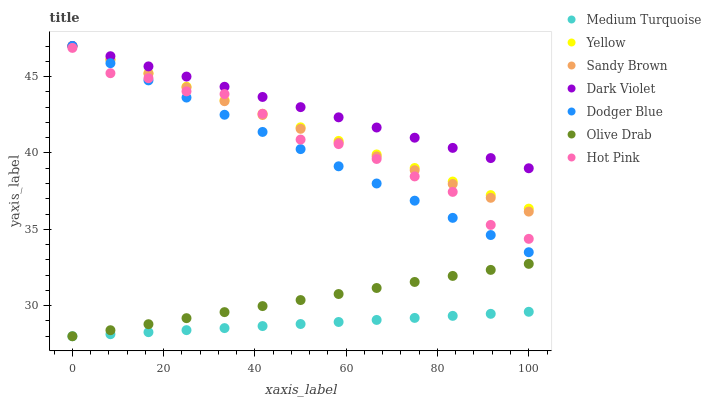Does Medium Turquoise have the minimum area under the curve?
Answer yes or no. Yes. Does Dark Violet have the maximum area under the curve?
Answer yes or no. Yes. Does Dodger Blue have the minimum area under the curve?
Answer yes or no. No. Does Dodger Blue have the maximum area under the curve?
Answer yes or no. No. Is Medium Turquoise the smoothest?
Answer yes or no. Yes. Is Hot Pink the roughest?
Answer yes or no. Yes. Is Dark Violet the smoothest?
Answer yes or no. No. Is Dark Violet the roughest?
Answer yes or no. No. Does Medium Turquoise have the lowest value?
Answer yes or no. Yes. Does Dodger Blue have the lowest value?
Answer yes or no. No. Does Sandy Brown have the highest value?
Answer yes or no. Yes. Does Medium Turquoise have the highest value?
Answer yes or no. No. Is Olive Drab less than Yellow?
Answer yes or no. Yes. Is Yellow greater than Medium Turquoise?
Answer yes or no. Yes. Does Sandy Brown intersect Dodger Blue?
Answer yes or no. Yes. Is Sandy Brown less than Dodger Blue?
Answer yes or no. No. Is Sandy Brown greater than Dodger Blue?
Answer yes or no. No. Does Olive Drab intersect Yellow?
Answer yes or no. No. 